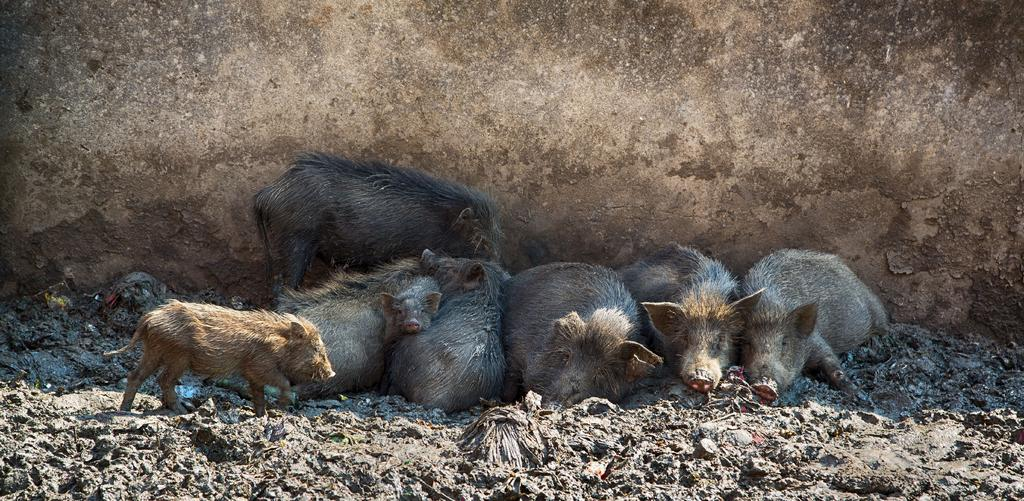What animals are present on the ground in the image? There are many pigs on the ground. What can be seen in the background of the image? There is a wall in the background of the image. What suggestion do the pigs have for improving the wall in the image? There is no indication in the image that the pigs have any suggestions for improving the wall, as they are animals and cannot communicate in that manner. 